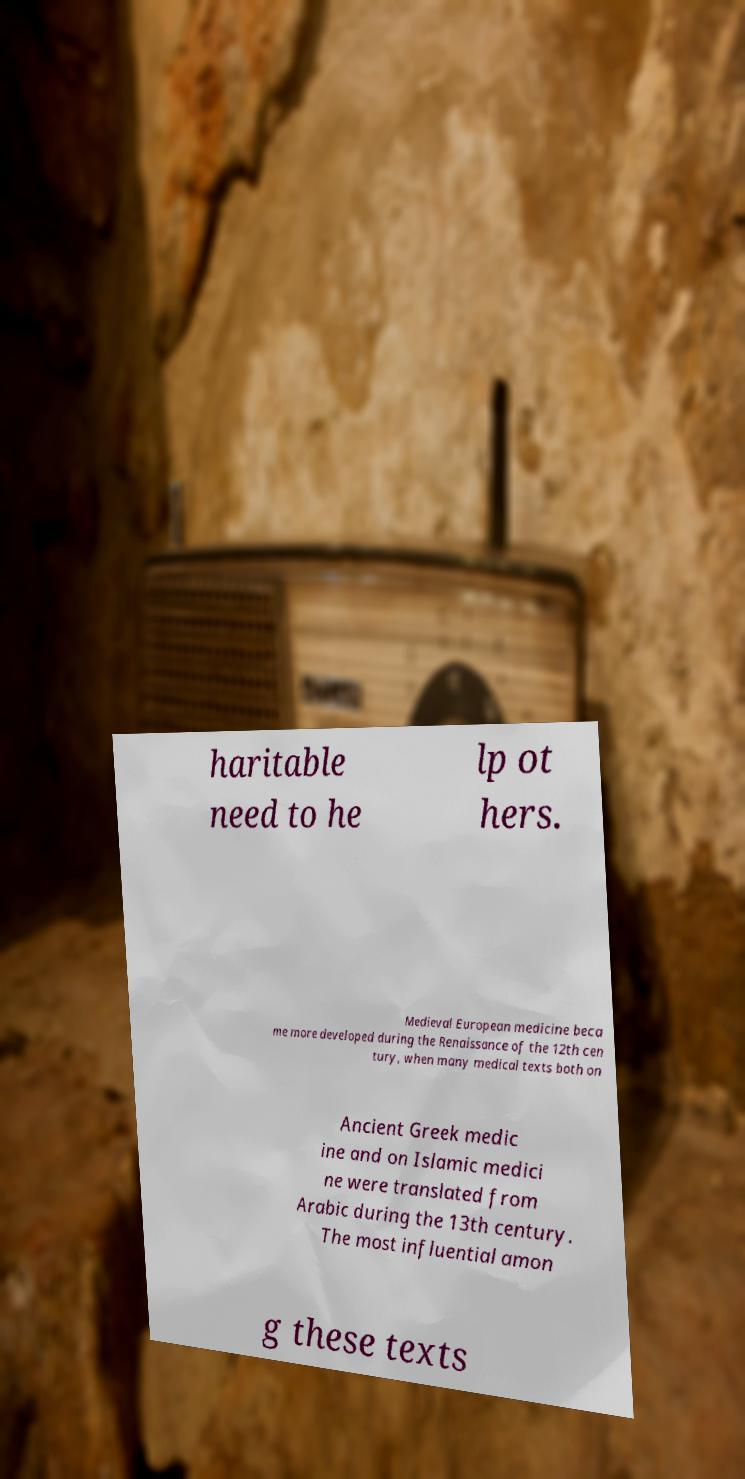There's text embedded in this image that I need extracted. Can you transcribe it verbatim? haritable need to he lp ot hers. Medieval European medicine beca me more developed during the Renaissance of the 12th cen tury, when many medical texts both on Ancient Greek medic ine and on Islamic medici ne were translated from Arabic during the 13th century. The most influential amon g these texts 